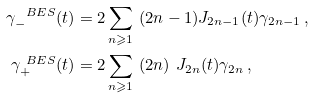Convert formula to latex. <formula><loc_0><loc_0><loc_500><loc_500>\gamma ^ { \ B E S } _ { - } ( t ) & = 2 \sum _ { n \geqslant 1 } \ ( 2 n - 1 ) J _ { 2 n - 1 } ( t ) \gamma _ { 2 n - 1 } \, , \\ \gamma ^ { \ B E S } _ { + } ( t ) & = 2 \sum _ { n \geqslant 1 } \ ( 2 n ) \ J _ { 2 n } ( t ) \gamma _ { 2 n } \, ,</formula> 